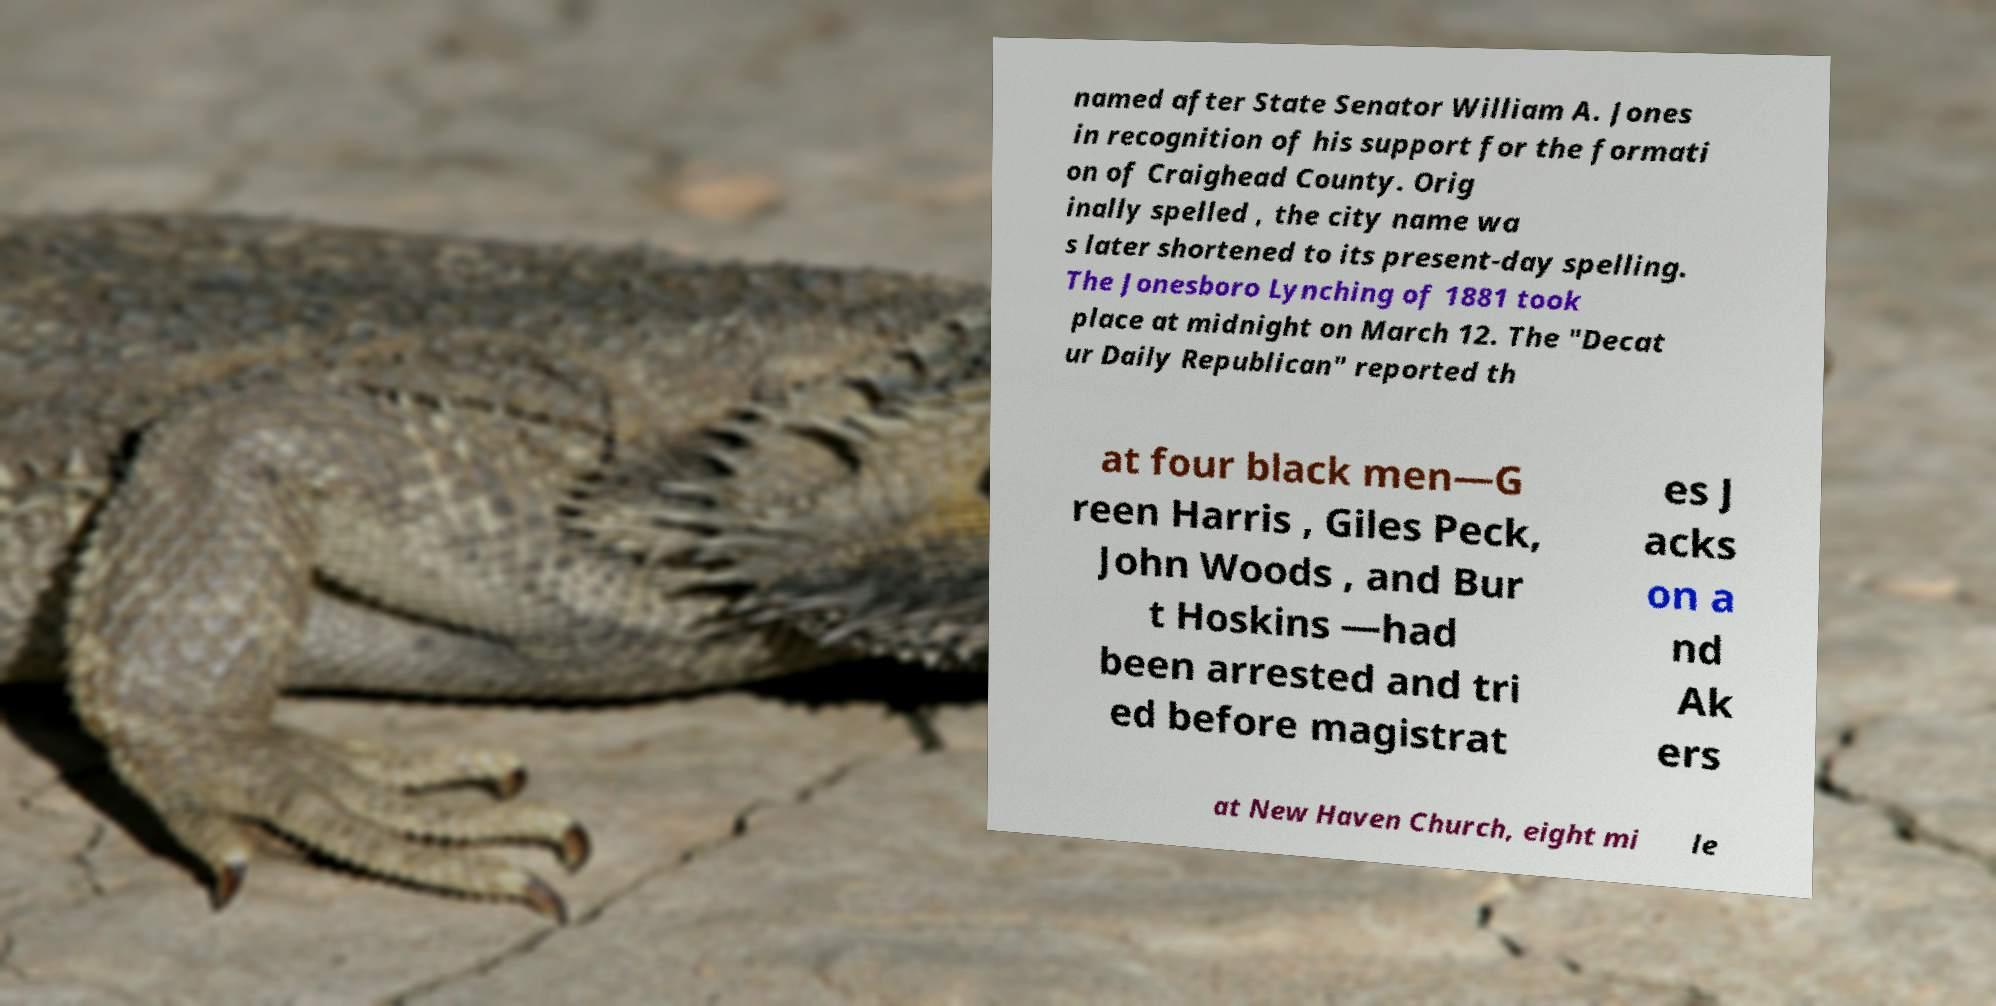Please read and relay the text visible in this image. What does it say? named after State Senator William A. Jones in recognition of his support for the formati on of Craighead County. Orig inally spelled , the city name wa s later shortened to its present-day spelling. The Jonesboro Lynching of 1881 took place at midnight on March 12. The "Decat ur Daily Republican" reported th at four black men—G reen Harris , Giles Peck, John Woods , and Bur t Hoskins —had been arrested and tri ed before magistrat es J acks on a nd Ak ers at New Haven Church, eight mi le 